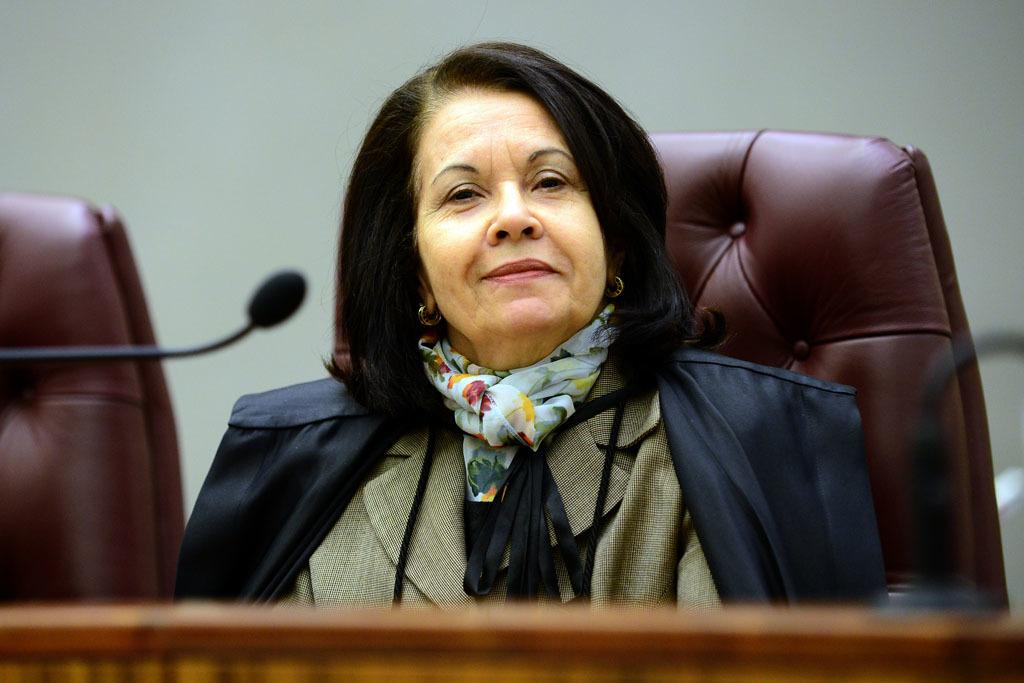Who is the main subject in the image? There is a woman in the image. What is the woman doing in the image? The woman is sitting on a chair. What is the woman wearing in the image? The woman is wearing a coat. What is the woman's facial expression in the image? The woman is smiling. What type of flesh can be seen on the woman's face in the image? There is no flesh visible on the woman's face in the image; she is wearing a coat that covers her body. 